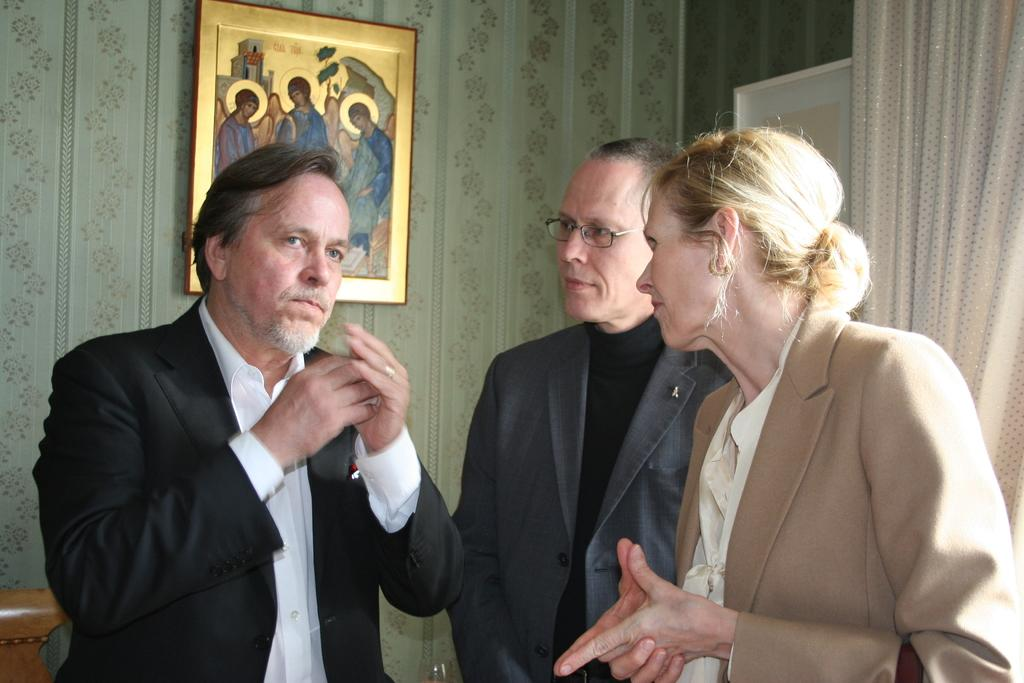How many people are present in the image? There are three people standing in the image. What can be seen in the background of the image? There is a curtain and a window in the image. Is there any decoration or object on the wall in the image? Yes, there is a photo frame on a wall in the image. What is in the foreground of the image? There is a glass in the foreground of the image. What type of pump is visible in the image? There is no pump present in the image. What is the income of the people in the image? The income of the people in the image cannot be determined from the image itself. 